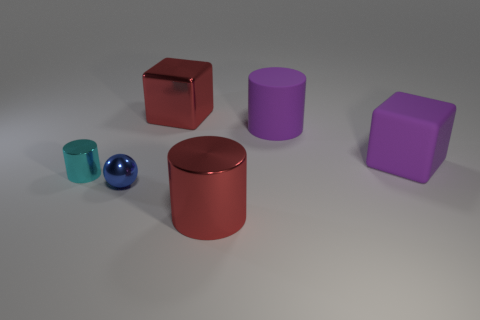There is a large block behind the purple rubber cube; is its color the same as the big shiny cylinder?
Give a very brief answer. Yes. There is a large metallic object behind the cylinder that is on the left side of the small blue thing; what shape is it?
Keep it short and to the point. Cube. How many objects are either small metallic things that are behind the tiny shiny sphere or objects in front of the blue shiny object?
Make the answer very short. 2. There is a large thing that is the same material as the large purple block; what shape is it?
Offer a very short reply. Cylinder. Is there any other thing of the same color as the ball?
Your response must be concise. No. What material is the red object that is the same shape as the tiny cyan thing?
Provide a short and direct response. Metal. How many other objects are the same size as the blue ball?
Offer a very short reply. 1. What material is the tiny blue thing?
Provide a succinct answer. Metal. Are there more metal cubes that are behind the purple cylinder than gray matte balls?
Offer a terse response. Yes. Is there a large red metal cylinder?
Offer a terse response. Yes. 